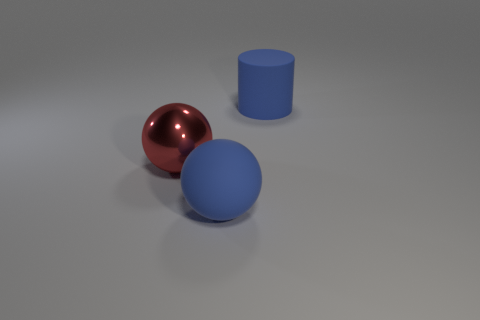What shape is the large thing that is behind the large blue rubber sphere and right of the large metallic ball?
Your answer should be compact. Cylinder. Are there any other things that have the same color as the big metal object?
Offer a terse response. No. There is a thing to the left of the big blue matte object in front of the large blue rubber object that is behind the red object; what is its shape?
Offer a terse response. Sphere. Do the blue object in front of the shiny ball and the blue object right of the rubber ball have the same size?
Your answer should be compact. Yes. How many cylinders have the same material as the blue sphere?
Your answer should be compact. 1. How many red spheres are on the right side of the blue object that is behind the blue object in front of the red thing?
Offer a terse response. 0. Are there any other big red things that have the same shape as the red thing?
Offer a terse response. No. There is a blue matte object that is the same size as the blue matte ball; what shape is it?
Offer a terse response. Cylinder. What is the material of the big blue cylinder that is to the right of the blue rubber object in front of the large red ball on the left side of the blue matte sphere?
Provide a succinct answer. Rubber. Is the size of the red ball the same as the blue cylinder?
Offer a terse response. Yes. 